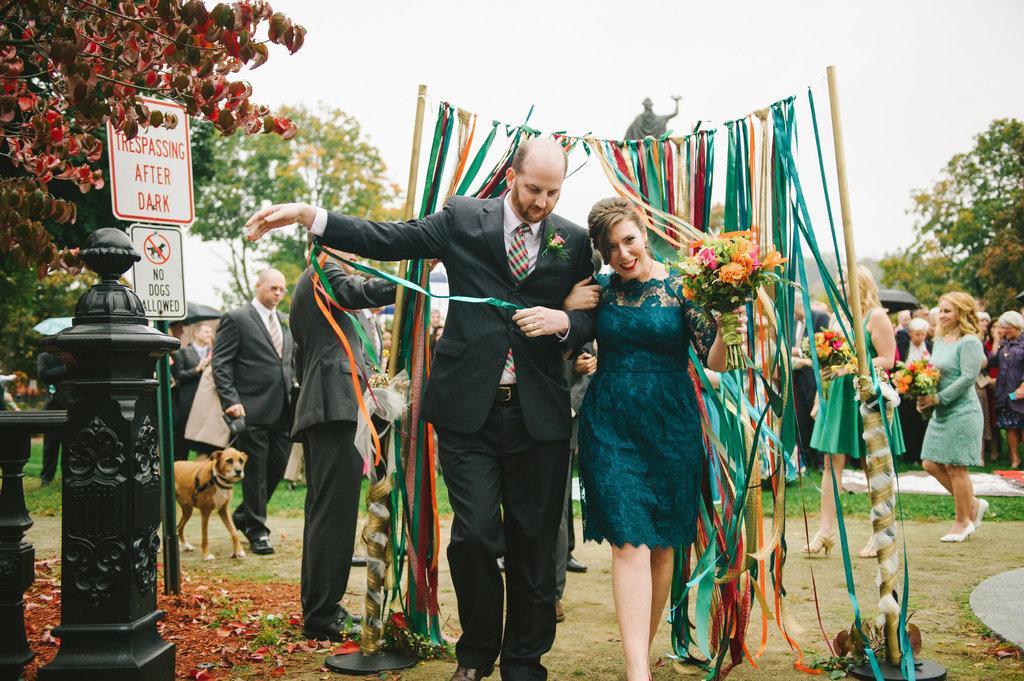Can you describe this image briefly? In the center of the image we can see a man and a lady and there is a bouquet in her hand. In the background there are ribbons, trees, boards, dog, pole, statue and sky. We can also see people walking. 